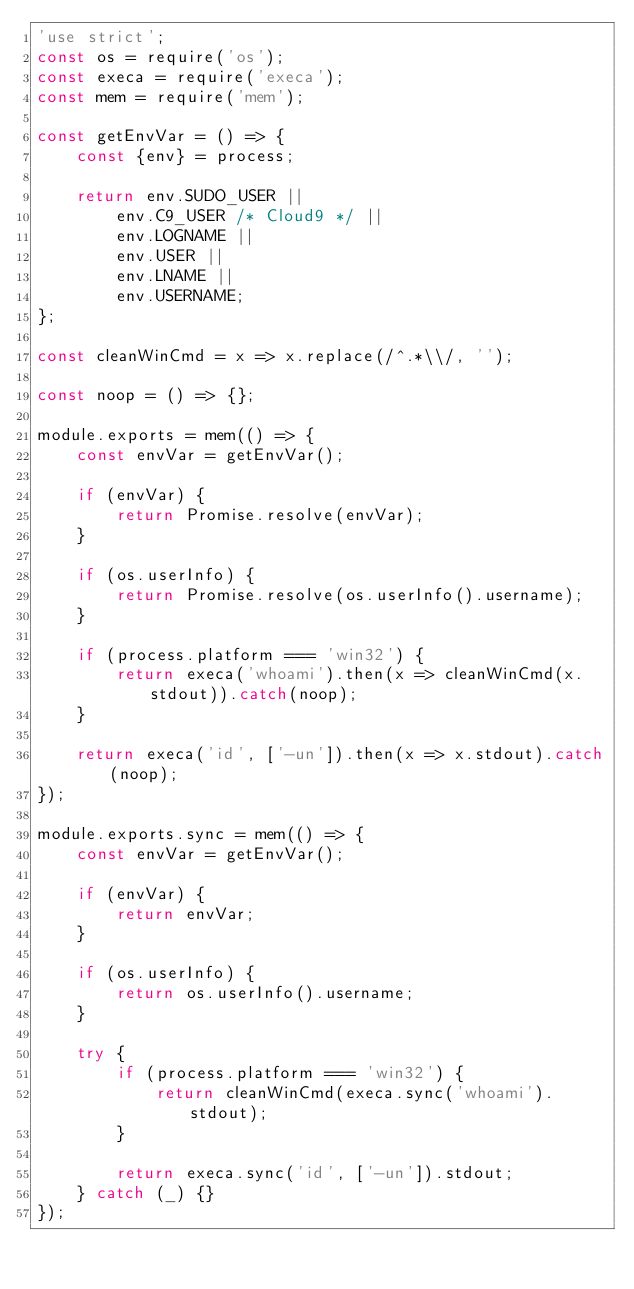Convert code to text. <code><loc_0><loc_0><loc_500><loc_500><_JavaScript_>'use strict';
const os = require('os');
const execa = require('execa');
const mem = require('mem');

const getEnvVar = () => {
	const {env} = process;

	return env.SUDO_USER ||
		env.C9_USER /* Cloud9 */ ||
		env.LOGNAME ||
		env.USER ||
		env.LNAME ||
		env.USERNAME;
};

const cleanWinCmd = x => x.replace(/^.*\\/, '');

const noop = () => {};

module.exports = mem(() => {
	const envVar = getEnvVar();

	if (envVar) {
		return Promise.resolve(envVar);
	}

	if (os.userInfo) {
		return Promise.resolve(os.userInfo().username);
	}

	if (process.platform === 'win32') {
		return execa('whoami').then(x => cleanWinCmd(x.stdout)).catch(noop);
	}

	return execa('id', ['-un']).then(x => x.stdout).catch(noop);
});

module.exports.sync = mem(() => {
	const envVar = getEnvVar();

	if (envVar) {
		return envVar;
	}

	if (os.userInfo) {
		return os.userInfo().username;
	}

	try {
		if (process.platform === 'win32') {
			return cleanWinCmd(execa.sync('whoami').stdout);
		}

		return execa.sync('id', ['-un']).stdout;
	} catch (_) {}
});
</code> 